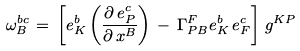<formula> <loc_0><loc_0><loc_500><loc_500>\omega _ { B } ^ { b c } \, = \, \left [ e ^ { b } _ { K } \left ( \frac { \partial \, e ^ { c } _ { P } } { \partial \, x ^ { B } } \right ) \, - \, \Gamma ^ { F } _ { P B } e ^ { b } _ { K } \, e ^ { c } _ { F } \right ] \, g ^ { K P }</formula> 